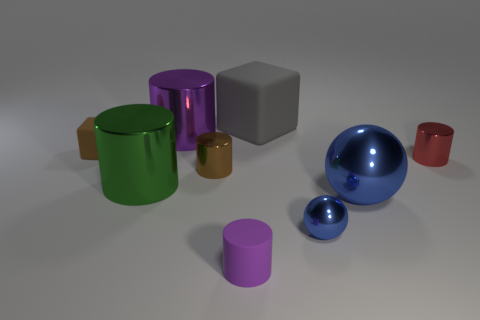Subtract all red cylinders. How many cylinders are left? 4 Subtract all tiny brown metal cylinders. How many cylinders are left? 4 Subtract 2 cylinders. How many cylinders are left? 3 Subtract all green cylinders. Subtract all green balls. How many cylinders are left? 4 Add 1 large yellow objects. How many objects exist? 10 Subtract all balls. How many objects are left? 7 Subtract all small brown objects. Subtract all metallic cylinders. How many objects are left? 3 Add 9 small brown metal cylinders. How many small brown metal cylinders are left? 10 Add 9 tiny brown cylinders. How many tiny brown cylinders exist? 10 Subtract 1 red cylinders. How many objects are left? 8 